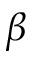Convert formula to latex. <formula><loc_0><loc_0><loc_500><loc_500>\beta</formula> 